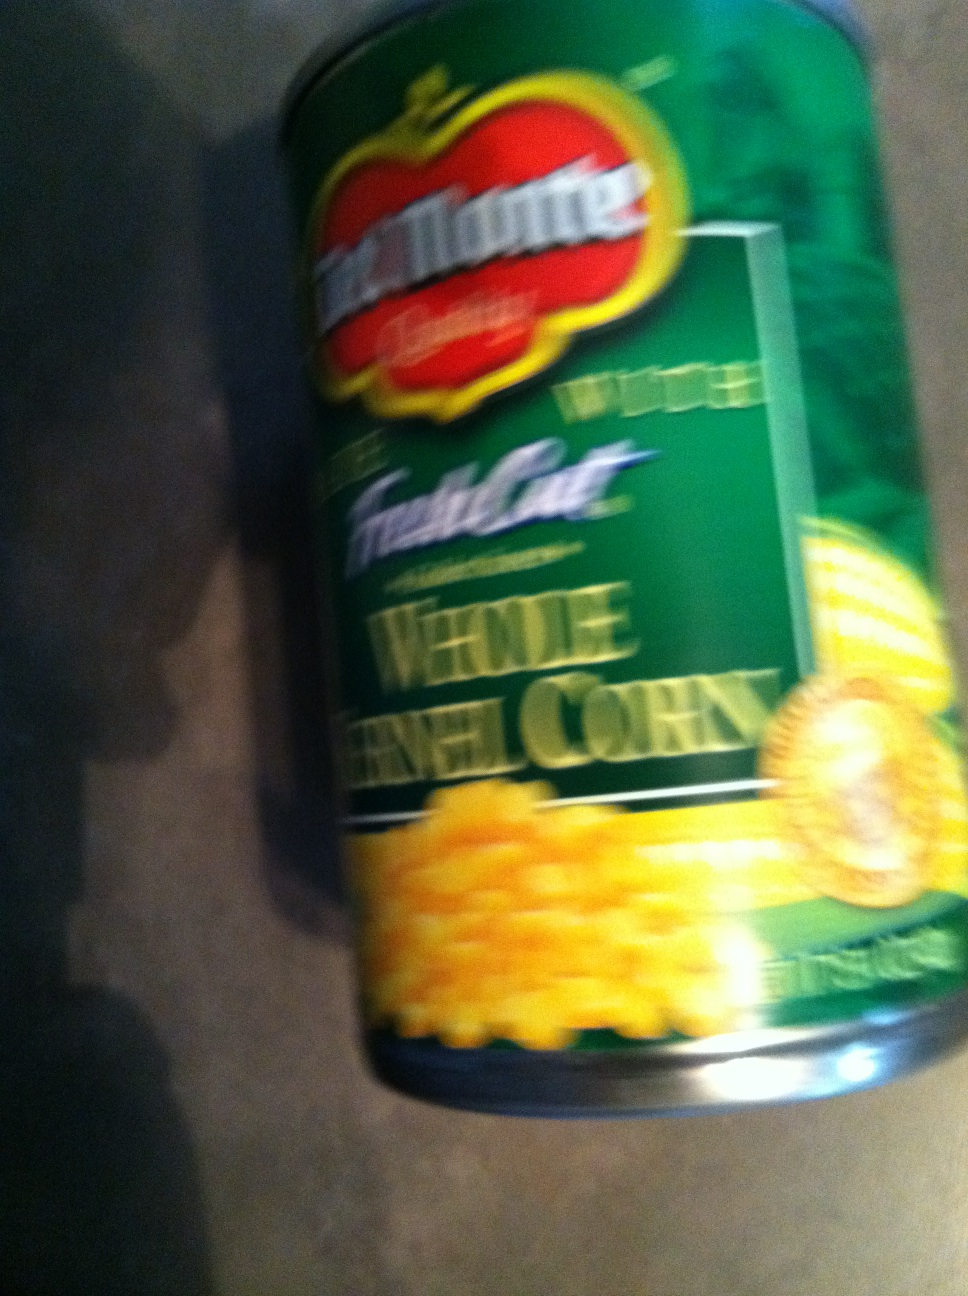What are some health benefits of whole kernel corn? Whole kernel corn is nutritious, offering dietary fiber, vitamins C and B, and essential minerals like magnesium and potassium. It's also a source of antioxidants, which can help combat oxidative stress in the body. Is corn gluten-free? Yes, corn is naturally gluten-free. It's a great grain option for those who are sensitive to gluten or have celiac disease. 